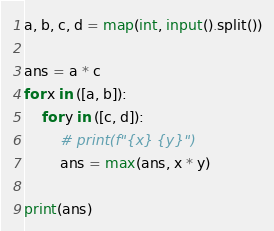Convert code to text. <code><loc_0><loc_0><loc_500><loc_500><_Python_>a, b, c, d = map(int, input().split())

ans = a * c
for x in ([a, b]):
    for y in ([c, d]):
        # print(f"{x} {y}")
        ans = max(ans, x * y)
        
print(ans)</code> 